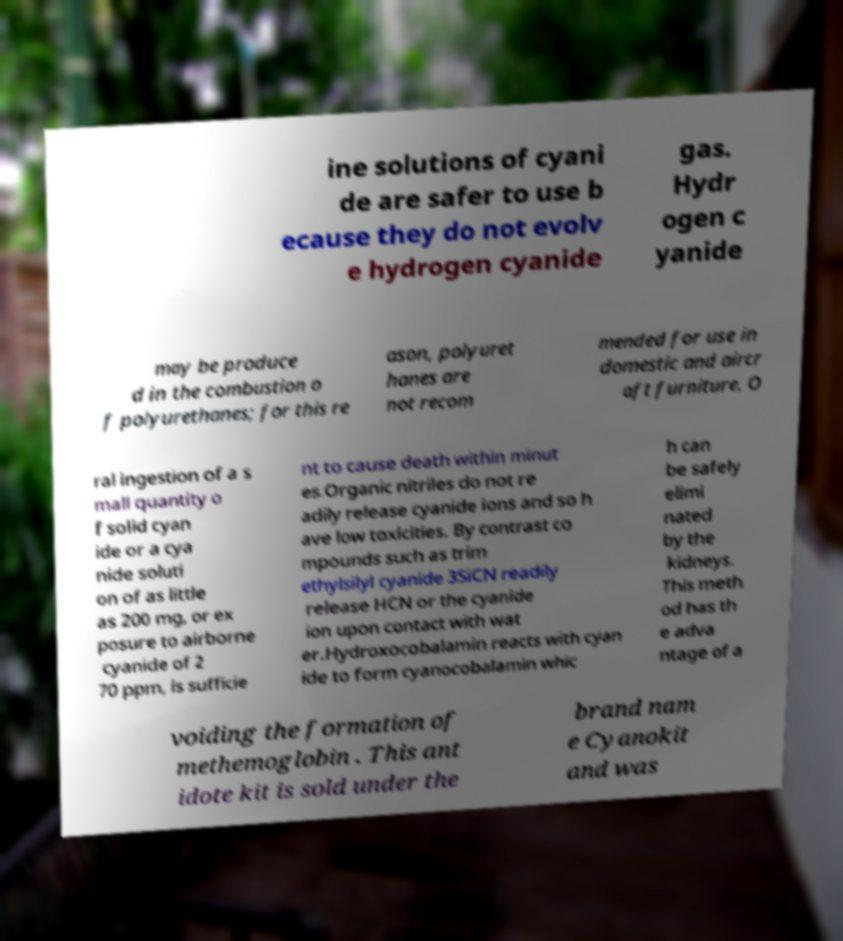Could you assist in decoding the text presented in this image and type it out clearly? ine solutions of cyani de are safer to use b ecause they do not evolv e hydrogen cyanide gas. Hydr ogen c yanide may be produce d in the combustion o f polyurethanes; for this re ason, polyuret hanes are not recom mended for use in domestic and aircr aft furniture. O ral ingestion of a s mall quantity o f solid cyan ide or a cya nide soluti on of as little as 200 mg, or ex posure to airborne cyanide of 2 70 ppm, is sufficie nt to cause death within minut es.Organic nitriles do not re adily release cyanide ions and so h ave low toxicities. By contrast co mpounds such as trim ethylsilyl cyanide 3SiCN readily release HCN or the cyanide ion upon contact with wat er.Hydroxocobalamin reacts with cyan ide to form cyanocobalamin whic h can be safely elimi nated by the kidneys. This meth od has th e adva ntage of a voiding the formation of methemoglobin . This ant idote kit is sold under the brand nam e Cyanokit and was 